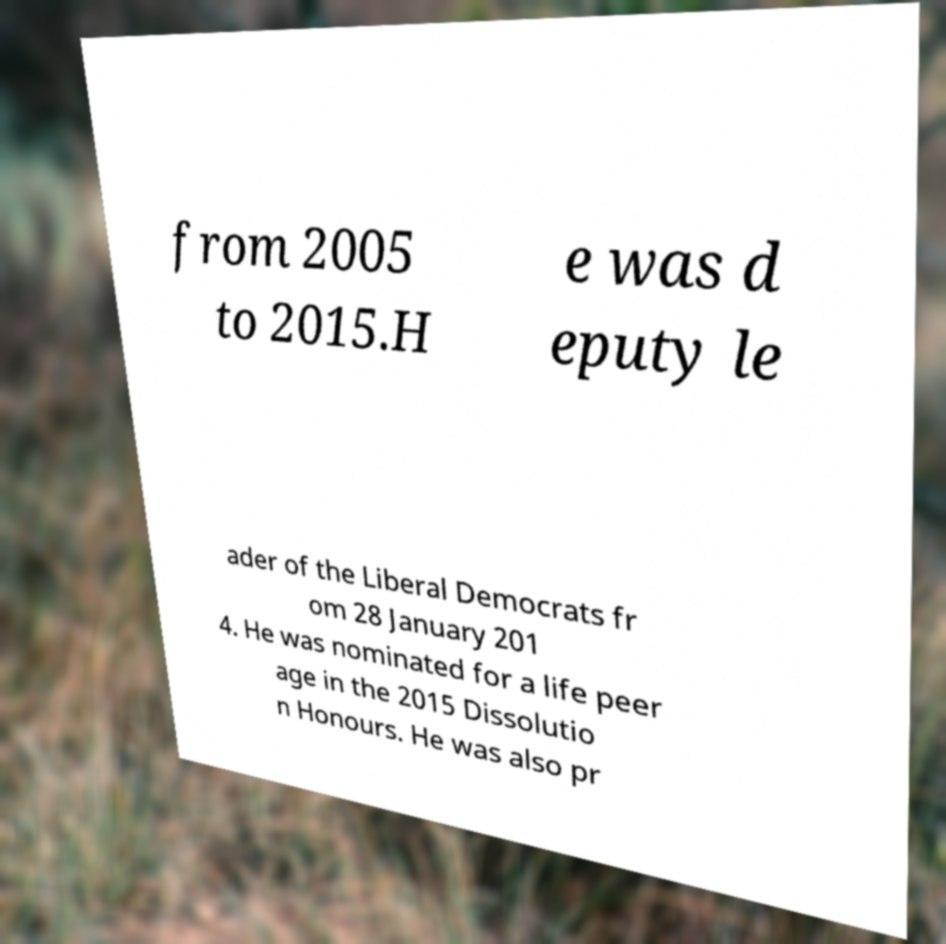Can you read and provide the text displayed in the image?This photo seems to have some interesting text. Can you extract and type it out for me? from 2005 to 2015.H e was d eputy le ader of the Liberal Democrats fr om 28 January 201 4. He was nominated for a life peer age in the 2015 Dissolutio n Honours. He was also pr 